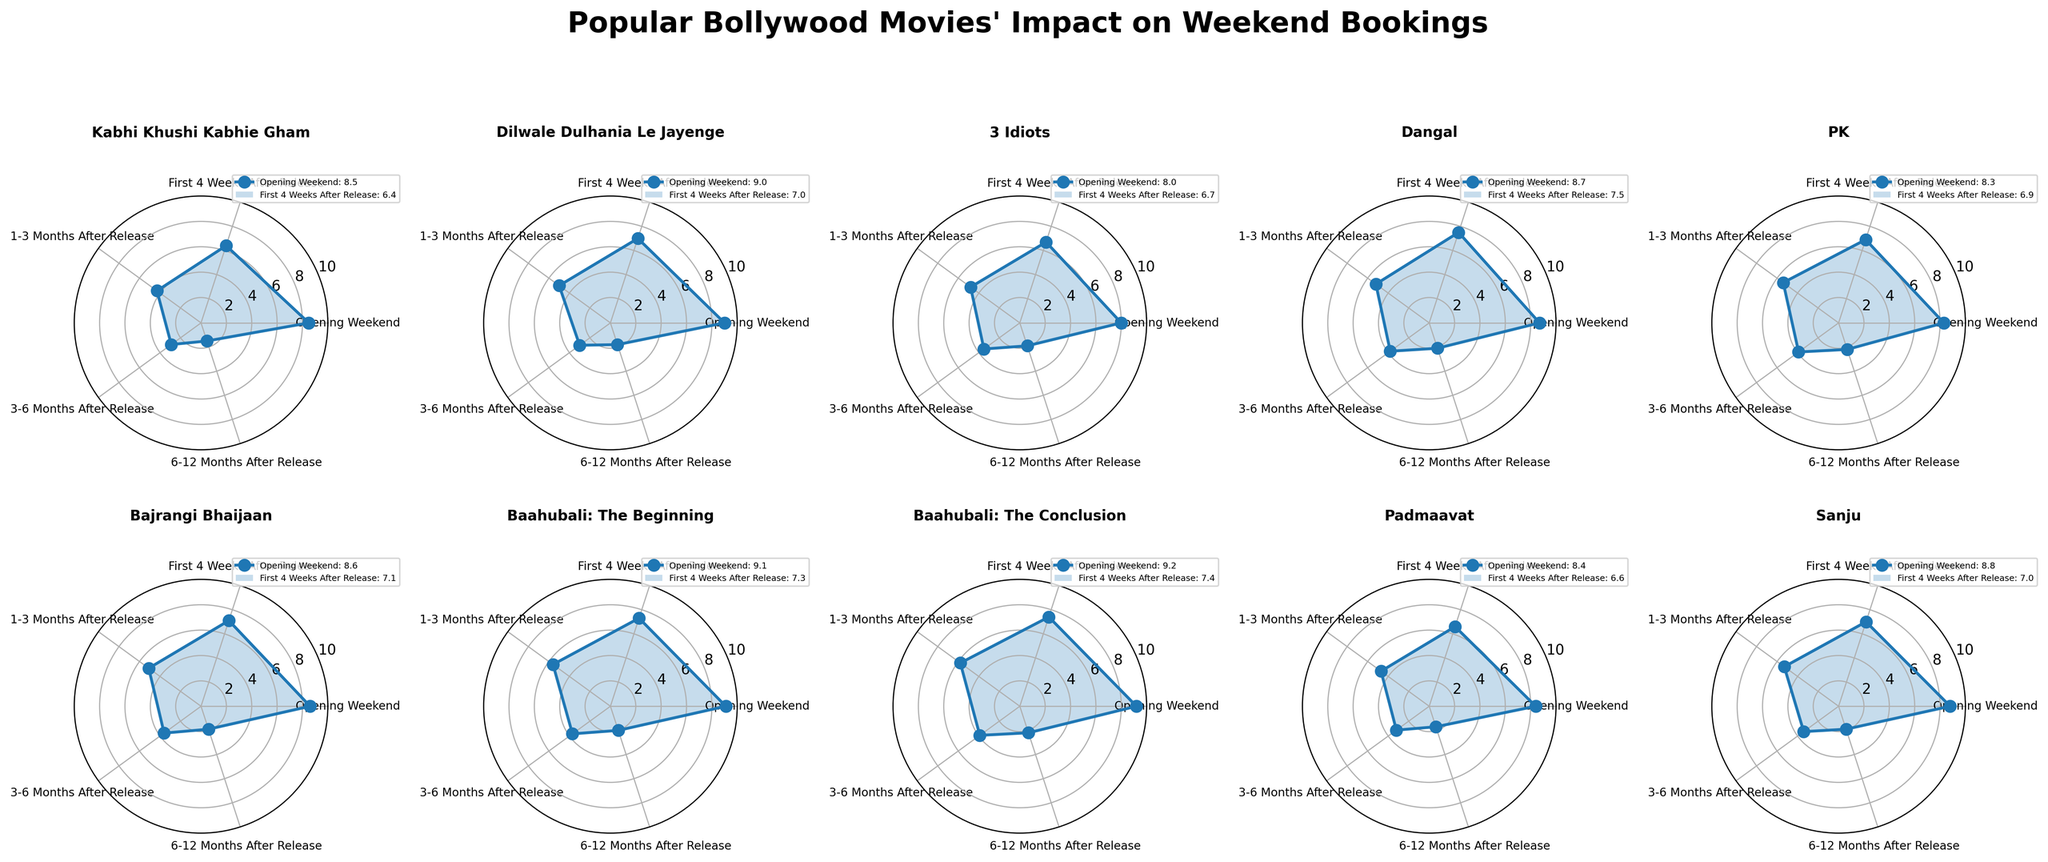Which movie has the highest impact during the opening weekend? Look at the first data point of each plot and find the movie with the highest value. "Baahubali: The Conclusion" has the highest value at 9.2.
Answer: Baahubali: The Conclusion Which movie has the lowest impact 3-6 months after release? Look at the fourth data point of each plot and find the movie with the lowest value. "Kabhi Khushi Kabhie Gham" has the lowest value at 2.9.
Answer: Kabhi Khushi Kabhie Gham What's the average impact of "Dangal" during the first 4 weeks after release and 6-12 months after release? Find the values for "Dangal" in the specified time periods (7.5 and 2.1), sum them up and divide by 2. (7.5 + 2.1) / 2 = 4.8
Answer: 4.8 Which movie shows the most consistent impact across all time periods? Consider consistency by examining plots with the least variation between data points. "3 Idiots" has relatively small differences across all time periods, indicating consistent impact.
Answer: 3 Idiots How does the impact of "Padmaavat" in 1-3 months after release compare to "Sanju" in the same period? Compare the third data point for both movies. "Padmaavat" has 4.7 and "Sanju" has 5.3. Thus, "Sanju" has a higher impact in that period.
Answer: Sanju has a higher impact Which two movies have the closest impact in the opening weekend? Compare the first data point for all movies. "PK" and "Kabhi Khushi Kabhie Gham" have very close values of 8.3 and 8.5, respectively.
Answer: PK and Kabhi Khushi Kabhie Gham Rank the movies based on their impact 1-3 months after release from highest to lowest. Assess the third data points for all movies and rank them. "Baahubali: The Conclusion" (5.8), "Baahubali: The Beginning" (5.6), "PK" (5.4), "Sanju" (5.3), "Dangal" (5.2), "Bajrangi Bhaijaan" (5.1), "Dilwale Dulhania Le Jayenge" (5.0), "3 Idiots" (4.8), "Padmaavat" (4.7), "Kabhi Khushi Kabhie Gham" (4.3).
Answer: Baahubali: The Conclusion, Baahubali: The Beginning, PK, Sanju, Dangal, Bajrangi Bhaijaan, Dilwale Dulhania Le Jayenge, 3 Idiots, Padmaavat, Kabhi Khushi Kabhie Gham How does the impact of "3 Idiots" in the first 4 weeks after release compare to "Bajrangi Bhaijaan" in the same period? Compare the second data point for both movies. "3 Idiots" has 6.7 and "Bajrangi Bhaijaan" has 7.1, so "Bajrangi Bhaijaan" has a higher impact in that period.
Answer: Bajrangi Bhaijaan has a higher impact Which movie has the highest overall impact combining all time periods? Sum the values of all time periods for each movie and find the highest. "Baahubali: The Conclusion" has the highest sum of 28.5 (9.2 + 7.4 + 5.8 + 3.9 + 2.2).
Answer: Baahubali: The Conclusion 